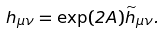<formula> <loc_0><loc_0><loc_500><loc_500>h _ { \mu \nu } = \exp ( 2 A ) { \widetilde { h } } _ { \mu \nu } .</formula> 